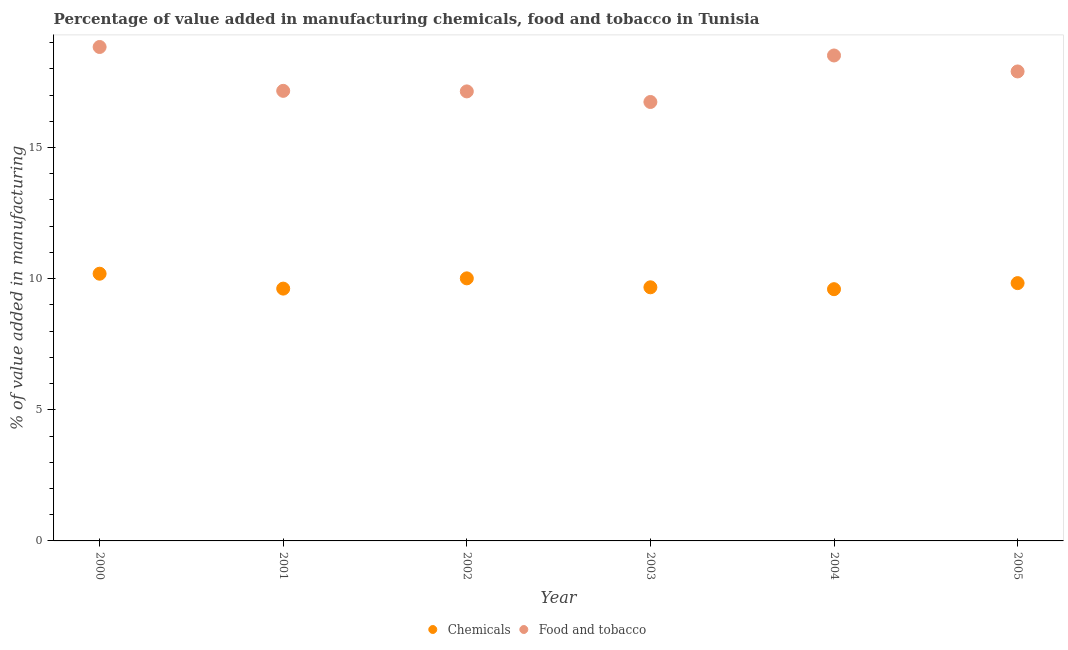How many different coloured dotlines are there?
Offer a terse response. 2. What is the value added by manufacturing food and tobacco in 2005?
Your response must be concise. 17.9. Across all years, what is the maximum value added by  manufacturing chemicals?
Provide a succinct answer. 10.19. Across all years, what is the minimum value added by manufacturing food and tobacco?
Provide a short and direct response. 16.74. In which year was the value added by manufacturing food and tobacco maximum?
Provide a short and direct response. 2000. In which year was the value added by  manufacturing chemicals minimum?
Keep it short and to the point. 2004. What is the total value added by manufacturing food and tobacco in the graph?
Ensure brevity in your answer.  106.28. What is the difference between the value added by manufacturing food and tobacco in 2001 and that in 2003?
Your response must be concise. 0.42. What is the difference between the value added by manufacturing food and tobacco in 2004 and the value added by  manufacturing chemicals in 2005?
Give a very brief answer. 8.68. What is the average value added by manufacturing food and tobacco per year?
Offer a terse response. 17.71. In the year 2001, what is the difference between the value added by manufacturing food and tobacco and value added by  manufacturing chemicals?
Keep it short and to the point. 7.54. In how many years, is the value added by manufacturing food and tobacco greater than 7 %?
Provide a succinct answer. 6. What is the ratio of the value added by  manufacturing chemicals in 2000 to that in 2005?
Give a very brief answer. 1.04. What is the difference between the highest and the second highest value added by manufacturing food and tobacco?
Provide a short and direct response. 0.32. What is the difference between the highest and the lowest value added by  manufacturing chemicals?
Keep it short and to the point. 0.59. Is the value added by manufacturing food and tobacco strictly greater than the value added by  manufacturing chemicals over the years?
Offer a terse response. Yes. Is the value added by manufacturing food and tobacco strictly less than the value added by  manufacturing chemicals over the years?
Keep it short and to the point. No. How many dotlines are there?
Your response must be concise. 2. Are the values on the major ticks of Y-axis written in scientific E-notation?
Provide a short and direct response. No. Does the graph contain grids?
Your answer should be compact. No. Where does the legend appear in the graph?
Your answer should be compact. Bottom center. How are the legend labels stacked?
Keep it short and to the point. Horizontal. What is the title of the graph?
Offer a terse response. Percentage of value added in manufacturing chemicals, food and tobacco in Tunisia. Does "Revenue" appear as one of the legend labels in the graph?
Give a very brief answer. No. What is the label or title of the Y-axis?
Offer a very short reply. % of value added in manufacturing. What is the % of value added in manufacturing of Chemicals in 2000?
Make the answer very short. 10.19. What is the % of value added in manufacturing in Food and tobacco in 2000?
Provide a succinct answer. 18.83. What is the % of value added in manufacturing of Chemicals in 2001?
Provide a succinct answer. 9.62. What is the % of value added in manufacturing of Food and tobacco in 2001?
Your response must be concise. 17.16. What is the % of value added in manufacturing of Chemicals in 2002?
Provide a short and direct response. 10.01. What is the % of value added in manufacturing of Food and tobacco in 2002?
Keep it short and to the point. 17.14. What is the % of value added in manufacturing in Chemicals in 2003?
Your answer should be very brief. 9.67. What is the % of value added in manufacturing in Food and tobacco in 2003?
Your answer should be compact. 16.74. What is the % of value added in manufacturing of Chemicals in 2004?
Your answer should be compact. 9.6. What is the % of value added in manufacturing in Food and tobacco in 2004?
Keep it short and to the point. 18.51. What is the % of value added in manufacturing of Chemicals in 2005?
Your answer should be compact. 9.83. What is the % of value added in manufacturing of Food and tobacco in 2005?
Your response must be concise. 17.9. Across all years, what is the maximum % of value added in manufacturing in Chemicals?
Offer a very short reply. 10.19. Across all years, what is the maximum % of value added in manufacturing of Food and tobacco?
Provide a succinct answer. 18.83. Across all years, what is the minimum % of value added in manufacturing of Chemicals?
Offer a very short reply. 9.6. Across all years, what is the minimum % of value added in manufacturing of Food and tobacco?
Provide a succinct answer. 16.74. What is the total % of value added in manufacturing in Chemicals in the graph?
Provide a succinct answer. 58.92. What is the total % of value added in manufacturing in Food and tobacco in the graph?
Keep it short and to the point. 106.28. What is the difference between the % of value added in manufacturing in Chemicals in 2000 and that in 2001?
Offer a very short reply. 0.57. What is the difference between the % of value added in manufacturing in Food and tobacco in 2000 and that in 2001?
Ensure brevity in your answer.  1.67. What is the difference between the % of value added in manufacturing of Chemicals in 2000 and that in 2002?
Keep it short and to the point. 0.18. What is the difference between the % of value added in manufacturing in Food and tobacco in 2000 and that in 2002?
Your answer should be very brief. 1.69. What is the difference between the % of value added in manufacturing in Chemicals in 2000 and that in 2003?
Keep it short and to the point. 0.52. What is the difference between the % of value added in manufacturing in Food and tobacco in 2000 and that in 2003?
Your answer should be very brief. 2.1. What is the difference between the % of value added in manufacturing of Chemicals in 2000 and that in 2004?
Give a very brief answer. 0.59. What is the difference between the % of value added in manufacturing of Food and tobacco in 2000 and that in 2004?
Your answer should be very brief. 0.32. What is the difference between the % of value added in manufacturing in Chemicals in 2000 and that in 2005?
Your response must be concise. 0.36. What is the difference between the % of value added in manufacturing of Food and tobacco in 2000 and that in 2005?
Provide a short and direct response. 0.93. What is the difference between the % of value added in manufacturing of Chemicals in 2001 and that in 2002?
Provide a short and direct response. -0.39. What is the difference between the % of value added in manufacturing in Food and tobacco in 2001 and that in 2002?
Offer a terse response. 0.02. What is the difference between the % of value added in manufacturing in Chemicals in 2001 and that in 2003?
Give a very brief answer. -0.05. What is the difference between the % of value added in manufacturing of Food and tobacco in 2001 and that in 2003?
Your answer should be compact. 0.42. What is the difference between the % of value added in manufacturing in Chemicals in 2001 and that in 2004?
Offer a terse response. 0.02. What is the difference between the % of value added in manufacturing of Food and tobacco in 2001 and that in 2004?
Offer a terse response. -1.35. What is the difference between the % of value added in manufacturing of Chemicals in 2001 and that in 2005?
Keep it short and to the point. -0.21. What is the difference between the % of value added in manufacturing of Food and tobacco in 2001 and that in 2005?
Your answer should be compact. -0.74. What is the difference between the % of value added in manufacturing in Chemicals in 2002 and that in 2003?
Ensure brevity in your answer.  0.34. What is the difference between the % of value added in manufacturing in Food and tobacco in 2002 and that in 2003?
Provide a succinct answer. 0.4. What is the difference between the % of value added in manufacturing in Chemicals in 2002 and that in 2004?
Provide a succinct answer. 0.41. What is the difference between the % of value added in manufacturing of Food and tobacco in 2002 and that in 2004?
Make the answer very short. -1.37. What is the difference between the % of value added in manufacturing in Chemicals in 2002 and that in 2005?
Provide a short and direct response. 0.18. What is the difference between the % of value added in manufacturing in Food and tobacco in 2002 and that in 2005?
Keep it short and to the point. -0.76. What is the difference between the % of value added in manufacturing of Chemicals in 2003 and that in 2004?
Give a very brief answer. 0.07. What is the difference between the % of value added in manufacturing of Food and tobacco in 2003 and that in 2004?
Provide a short and direct response. -1.77. What is the difference between the % of value added in manufacturing in Chemicals in 2003 and that in 2005?
Make the answer very short. -0.16. What is the difference between the % of value added in manufacturing in Food and tobacco in 2003 and that in 2005?
Give a very brief answer. -1.16. What is the difference between the % of value added in manufacturing in Chemicals in 2004 and that in 2005?
Your answer should be very brief. -0.23. What is the difference between the % of value added in manufacturing of Food and tobacco in 2004 and that in 2005?
Ensure brevity in your answer.  0.61. What is the difference between the % of value added in manufacturing of Chemicals in 2000 and the % of value added in manufacturing of Food and tobacco in 2001?
Provide a short and direct response. -6.97. What is the difference between the % of value added in manufacturing of Chemicals in 2000 and the % of value added in manufacturing of Food and tobacco in 2002?
Your answer should be very brief. -6.95. What is the difference between the % of value added in manufacturing in Chemicals in 2000 and the % of value added in manufacturing in Food and tobacco in 2003?
Offer a terse response. -6.55. What is the difference between the % of value added in manufacturing in Chemicals in 2000 and the % of value added in manufacturing in Food and tobacco in 2004?
Provide a succinct answer. -8.32. What is the difference between the % of value added in manufacturing in Chemicals in 2000 and the % of value added in manufacturing in Food and tobacco in 2005?
Your response must be concise. -7.71. What is the difference between the % of value added in manufacturing in Chemicals in 2001 and the % of value added in manufacturing in Food and tobacco in 2002?
Your answer should be compact. -7.52. What is the difference between the % of value added in manufacturing of Chemicals in 2001 and the % of value added in manufacturing of Food and tobacco in 2003?
Your answer should be very brief. -7.12. What is the difference between the % of value added in manufacturing in Chemicals in 2001 and the % of value added in manufacturing in Food and tobacco in 2004?
Provide a succinct answer. -8.89. What is the difference between the % of value added in manufacturing of Chemicals in 2001 and the % of value added in manufacturing of Food and tobacco in 2005?
Make the answer very short. -8.28. What is the difference between the % of value added in manufacturing of Chemicals in 2002 and the % of value added in manufacturing of Food and tobacco in 2003?
Offer a terse response. -6.72. What is the difference between the % of value added in manufacturing of Chemicals in 2002 and the % of value added in manufacturing of Food and tobacco in 2004?
Provide a short and direct response. -8.5. What is the difference between the % of value added in manufacturing in Chemicals in 2002 and the % of value added in manufacturing in Food and tobacco in 2005?
Your answer should be compact. -7.89. What is the difference between the % of value added in manufacturing in Chemicals in 2003 and the % of value added in manufacturing in Food and tobacco in 2004?
Offer a terse response. -8.84. What is the difference between the % of value added in manufacturing of Chemicals in 2003 and the % of value added in manufacturing of Food and tobacco in 2005?
Make the answer very short. -8.23. What is the difference between the % of value added in manufacturing in Chemicals in 2004 and the % of value added in manufacturing in Food and tobacco in 2005?
Your response must be concise. -8.3. What is the average % of value added in manufacturing in Chemicals per year?
Offer a terse response. 9.82. What is the average % of value added in manufacturing in Food and tobacco per year?
Your response must be concise. 17.71. In the year 2000, what is the difference between the % of value added in manufacturing of Chemicals and % of value added in manufacturing of Food and tobacco?
Keep it short and to the point. -8.64. In the year 2001, what is the difference between the % of value added in manufacturing in Chemicals and % of value added in manufacturing in Food and tobacco?
Your answer should be very brief. -7.54. In the year 2002, what is the difference between the % of value added in manufacturing in Chemicals and % of value added in manufacturing in Food and tobacco?
Give a very brief answer. -7.13. In the year 2003, what is the difference between the % of value added in manufacturing of Chemicals and % of value added in manufacturing of Food and tobacco?
Provide a short and direct response. -7.07. In the year 2004, what is the difference between the % of value added in manufacturing of Chemicals and % of value added in manufacturing of Food and tobacco?
Give a very brief answer. -8.91. In the year 2005, what is the difference between the % of value added in manufacturing of Chemicals and % of value added in manufacturing of Food and tobacco?
Ensure brevity in your answer.  -8.07. What is the ratio of the % of value added in manufacturing in Chemicals in 2000 to that in 2001?
Your response must be concise. 1.06. What is the ratio of the % of value added in manufacturing in Food and tobacco in 2000 to that in 2001?
Your answer should be very brief. 1.1. What is the ratio of the % of value added in manufacturing of Chemicals in 2000 to that in 2002?
Keep it short and to the point. 1.02. What is the ratio of the % of value added in manufacturing in Food and tobacco in 2000 to that in 2002?
Make the answer very short. 1.1. What is the ratio of the % of value added in manufacturing of Chemicals in 2000 to that in 2003?
Provide a succinct answer. 1.05. What is the ratio of the % of value added in manufacturing of Food and tobacco in 2000 to that in 2003?
Offer a terse response. 1.13. What is the ratio of the % of value added in manufacturing of Chemicals in 2000 to that in 2004?
Make the answer very short. 1.06. What is the ratio of the % of value added in manufacturing in Food and tobacco in 2000 to that in 2004?
Ensure brevity in your answer.  1.02. What is the ratio of the % of value added in manufacturing in Chemicals in 2000 to that in 2005?
Keep it short and to the point. 1.04. What is the ratio of the % of value added in manufacturing of Food and tobacco in 2000 to that in 2005?
Provide a succinct answer. 1.05. What is the ratio of the % of value added in manufacturing in Chemicals in 2001 to that in 2002?
Provide a short and direct response. 0.96. What is the ratio of the % of value added in manufacturing in Chemicals in 2001 to that in 2003?
Provide a short and direct response. 0.99. What is the ratio of the % of value added in manufacturing in Food and tobacco in 2001 to that in 2003?
Your answer should be very brief. 1.03. What is the ratio of the % of value added in manufacturing in Food and tobacco in 2001 to that in 2004?
Your answer should be very brief. 0.93. What is the ratio of the % of value added in manufacturing of Chemicals in 2001 to that in 2005?
Your answer should be compact. 0.98. What is the ratio of the % of value added in manufacturing of Food and tobacco in 2001 to that in 2005?
Provide a succinct answer. 0.96. What is the ratio of the % of value added in manufacturing of Chemicals in 2002 to that in 2003?
Give a very brief answer. 1.04. What is the ratio of the % of value added in manufacturing in Food and tobacco in 2002 to that in 2003?
Provide a succinct answer. 1.02. What is the ratio of the % of value added in manufacturing of Chemicals in 2002 to that in 2004?
Make the answer very short. 1.04. What is the ratio of the % of value added in manufacturing in Food and tobacco in 2002 to that in 2004?
Make the answer very short. 0.93. What is the ratio of the % of value added in manufacturing in Chemicals in 2002 to that in 2005?
Ensure brevity in your answer.  1.02. What is the ratio of the % of value added in manufacturing of Food and tobacco in 2002 to that in 2005?
Your response must be concise. 0.96. What is the ratio of the % of value added in manufacturing of Chemicals in 2003 to that in 2004?
Offer a very short reply. 1.01. What is the ratio of the % of value added in manufacturing in Food and tobacco in 2003 to that in 2004?
Keep it short and to the point. 0.9. What is the ratio of the % of value added in manufacturing of Chemicals in 2003 to that in 2005?
Your answer should be compact. 0.98. What is the ratio of the % of value added in manufacturing of Food and tobacco in 2003 to that in 2005?
Your answer should be very brief. 0.94. What is the ratio of the % of value added in manufacturing in Chemicals in 2004 to that in 2005?
Make the answer very short. 0.98. What is the ratio of the % of value added in manufacturing in Food and tobacco in 2004 to that in 2005?
Your answer should be very brief. 1.03. What is the difference between the highest and the second highest % of value added in manufacturing of Chemicals?
Your answer should be very brief. 0.18. What is the difference between the highest and the second highest % of value added in manufacturing of Food and tobacco?
Provide a succinct answer. 0.32. What is the difference between the highest and the lowest % of value added in manufacturing of Chemicals?
Your response must be concise. 0.59. What is the difference between the highest and the lowest % of value added in manufacturing of Food and tobacco?
Provide a short and direct response. 2.1. 